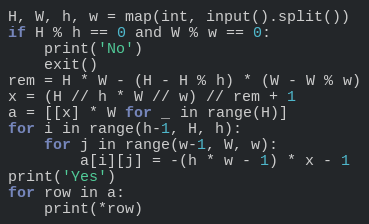Convert code to text. <code><loc_0><loc_0><loc_500><loc_500><_Python_>H, W, h, w = map(int, input().split())
if H % h == 0 and W % w == 0:
    print('No')
    exit()
rem = H * W - (H - H % h) * (W - W % w)
x = (H // h * W // w) // rem + 1
a = [[x] * W for _ in range(H)]
for i in range(h-1, H, h):
    for j in range(w-1, W, w):
        a[i][j] = -(h * w - 1) * x - 1
print('Yes')
for row in a:
    print(*row)
</code> 